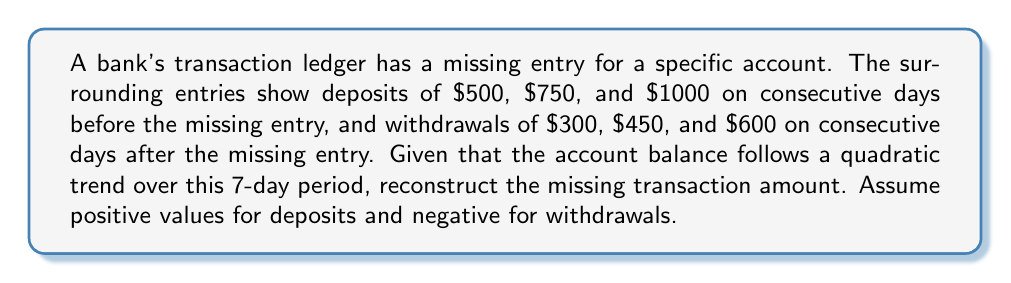Show me your answer to this math problem. Let's approach this step-by-step:

1) Let's number the days from 1 to 7, with the missing entry on day 4.

2) We can represent the daily balances with a quadratic function:
   $$B(t) = at^2 + bt + c$$
   where $t$ is the day number, and $a$, $b$, and $c$ are constants to be determined.

3) We know the daily changes (transactions) for 6 out of 7 days:
   Day 1: +500
   Day 2: +750
   Day 3: +1000
   Day 4: Unknown (let's call it $x$)
   Day 5: -300
   Day 6: -450
   Day 7: -600

4) The daily change is the derivative of the balance function:
   $$B'(t) = 2at + b$$

5) We can set up three equations using days 1, 3, and 7:
   $$2a(1) + b = 500$$
   $$2a(3) + b = 1000$$
   $$2a(7) + b = -600$$

6) Subtracting the first equation from the second:
   $$4a = 500$$
   $$a = 125$$

7) Substituting this back into the first equation:
   $$250 + b = 500$$
   $$b = 250$$

8) We can verify these values satisfy the third equation:
   $$2(125)(7) + 250 = 1750 + 250 = 2000 = -600$$

9) Now we have $B'(t) = 250t + 250$

10) To find the missing transaction on day 4, we calculate:
    $$B'(4) = 250(4) + 250 = 1250$$

Therefore, the missing transaction is a deposit of $1250.
Answer: $1250 